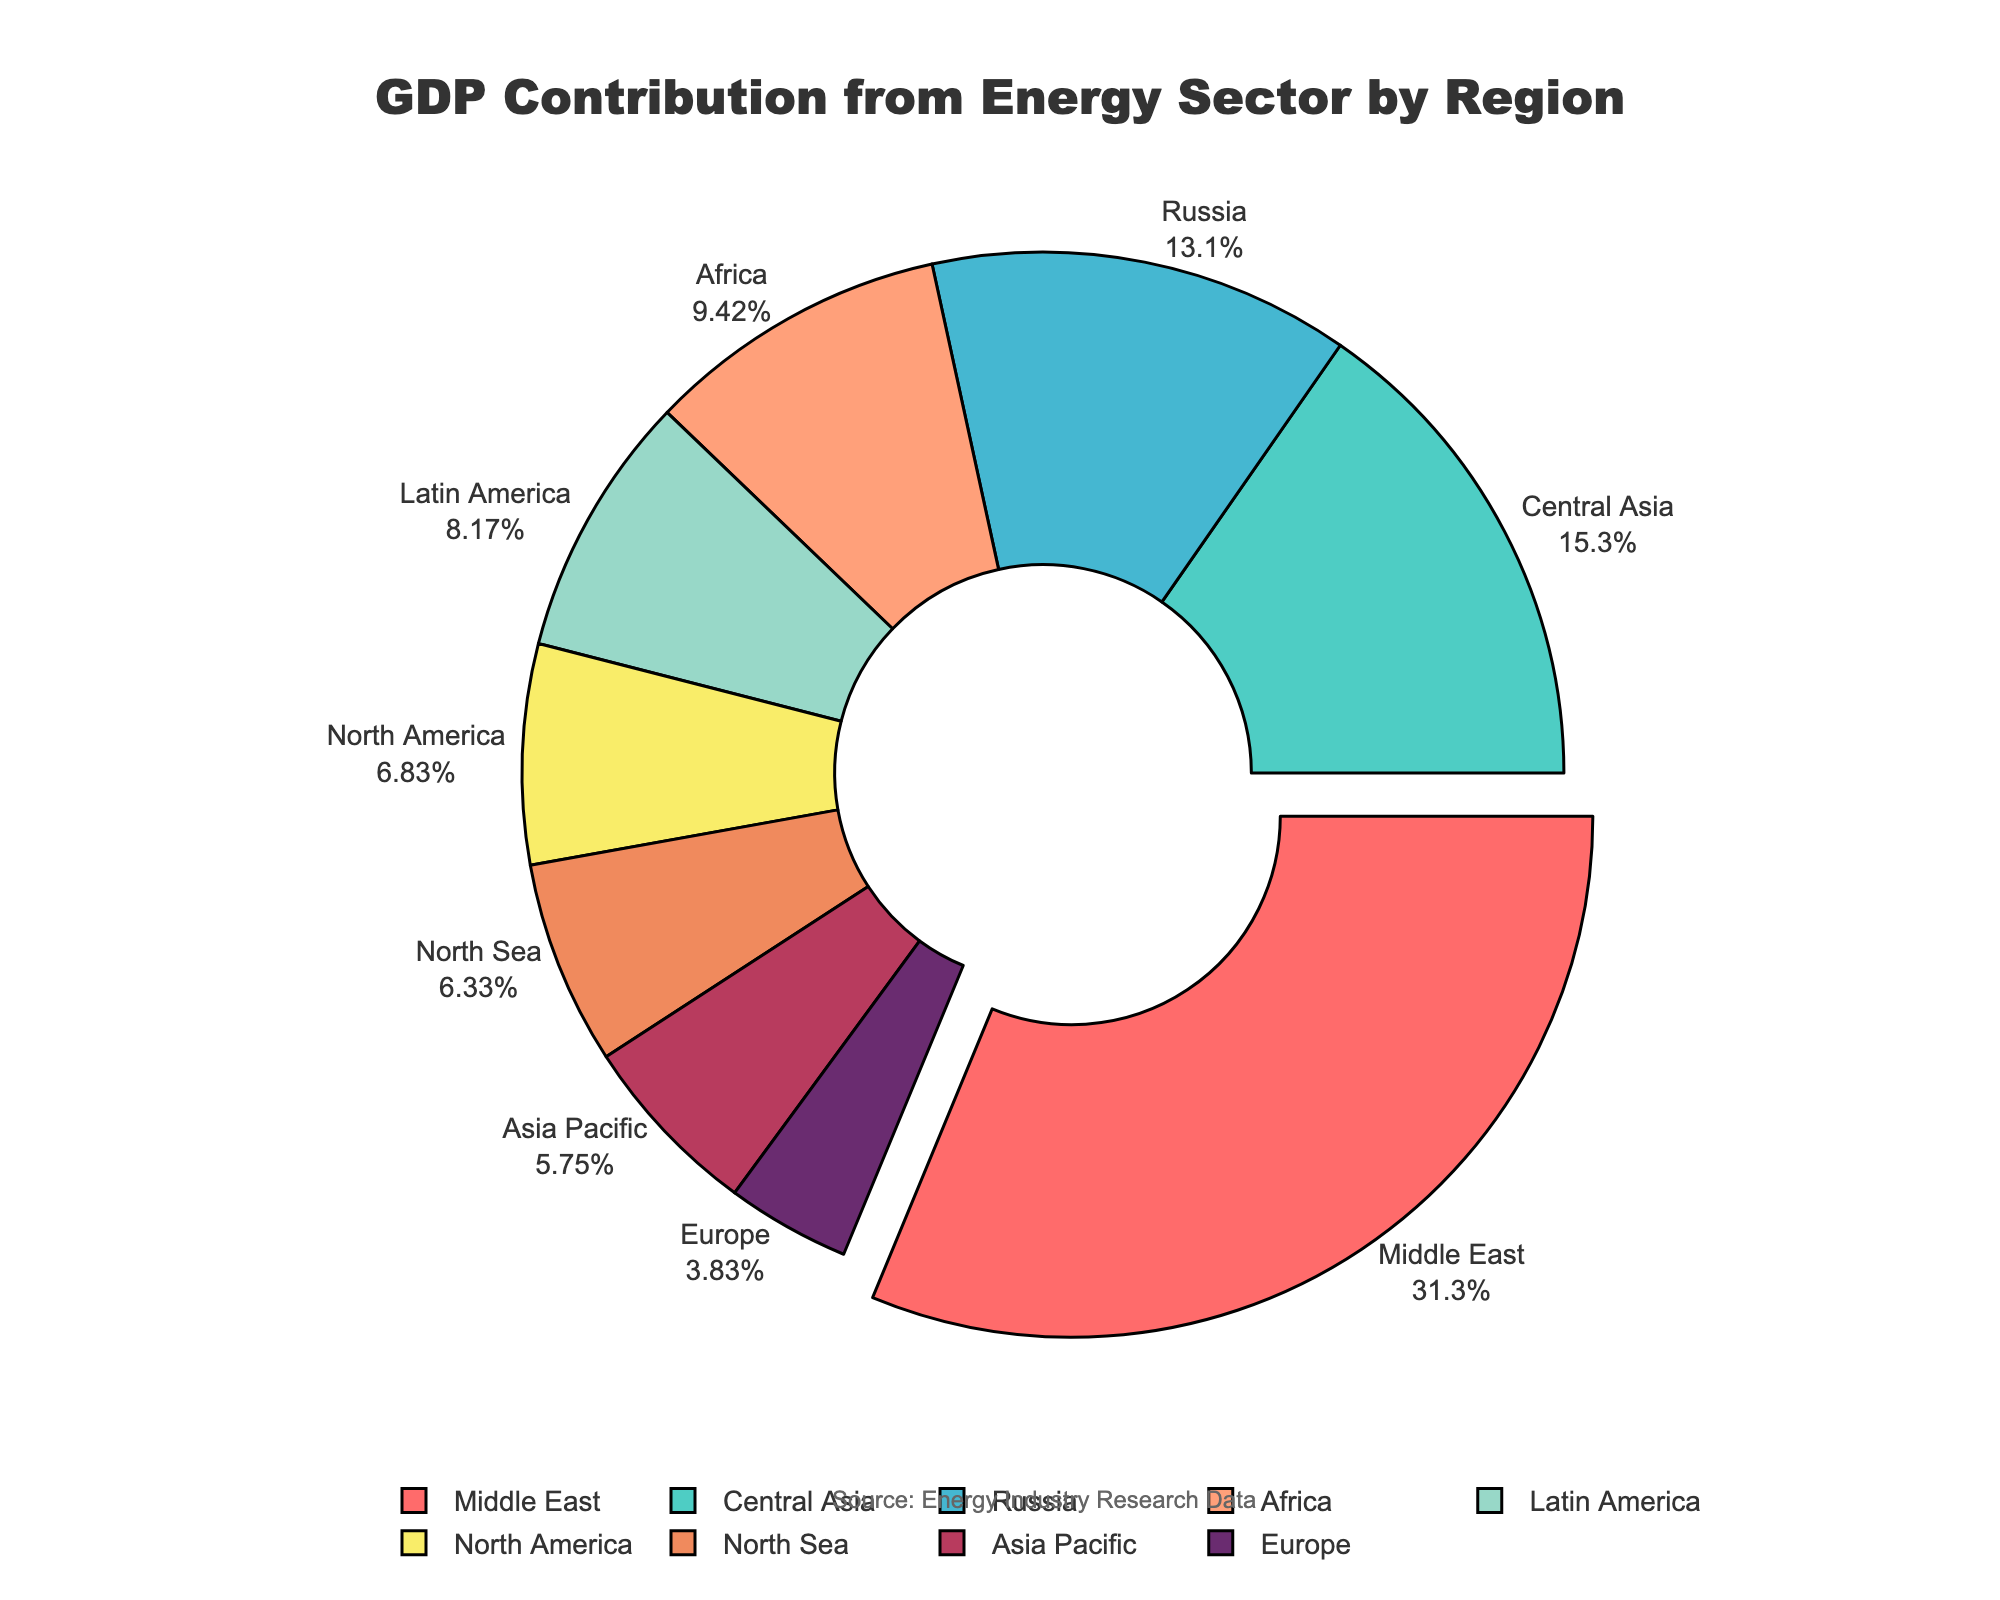Which region contributes the most to the GDP from the energy sector? The Middle East is pulled out slightly in the pie chart, indicating it has the highest contribution percentage.
Answer: Middle East Which region contributes the least to the GDP from the energy sector? Europe has the smallest segment in the pie chart, indicating the lowest contribution percentage.
Answer: Europe How much more does the Middle East contribute to GDP compared to North America? The contribution of the Middle East is 37.5%, while North America's contribution is 8.2%. The difference is 37.5% - 8.2%.
Answer: 29.3 What is the total GDP contribution percentage from regions contributing more than 10%? The regions contributing more than 10% are Middle East (37.5%), Russia (15.7%), Africa (11.3%), and Central Asia (18.4%). Adding these percentages: 37.5 + 15.7 + 11.3 + 18.4 = 82.9.
Answer: 82.9 Which region contributes more to GDP from the energy sector: Africa or Latin America? Africa's contribution is 11.3%, while Latin America's contribution is 9.8%. Comparatively, Africa contributes more.
Answer: Africa By how much does Central Asia's GDP contribution from the energy sector exceed that of the North Sea? Central Asia's contribution is 18.4%, and the North Sea's contribution is 7.6%. The difference is 18.4% - 7.6%.
Answer: 10.8 What percentage of GDP contribution comes from regions contributing less than 10%? The regions contributing less than 10% are North America (8.2%), Latin America (9.8%), Europe (4.6%), and Asia Pacific (6.9%). Adding these percentages: 8.2 + 9.8 + 4.6 + 6.9 = 29.5.
Answer: 29.5 Which regions' contributions are visually similar in size on the pie chart? The sections for North America (8.2%), Asia Pacific (6.9%), and North Sea (7.6%) appear visually similar in size.
Answer: North America, Asia Pacific, North Sea 